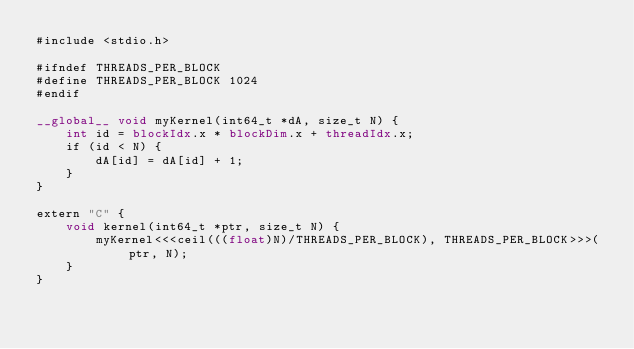Convert code to text. <code><loc_0><loc_0><loc_500><loc_500><_Cuda_>#include <stdio.h>

#ifndef THREADS_PER_BLOCK
#define THREADS_PER_BLOCK 1024
#endif

__global__ void myKernel(int64_t *dA, size_t N) {
    int id = blockIdx.x * blockDim.x + threadIdx.x;
    if (id < N) {
        dA[id] = dA[id] + 1;
    }
}

extern "C" {
    void kernel(int64_t *ptr, size_t N) {
        myKernel<<<ceil(((float)N)/THREADS_PER_BLOCK), THREADS_PER_BLOCK>>>(ptr, N);
    }
}</code> 